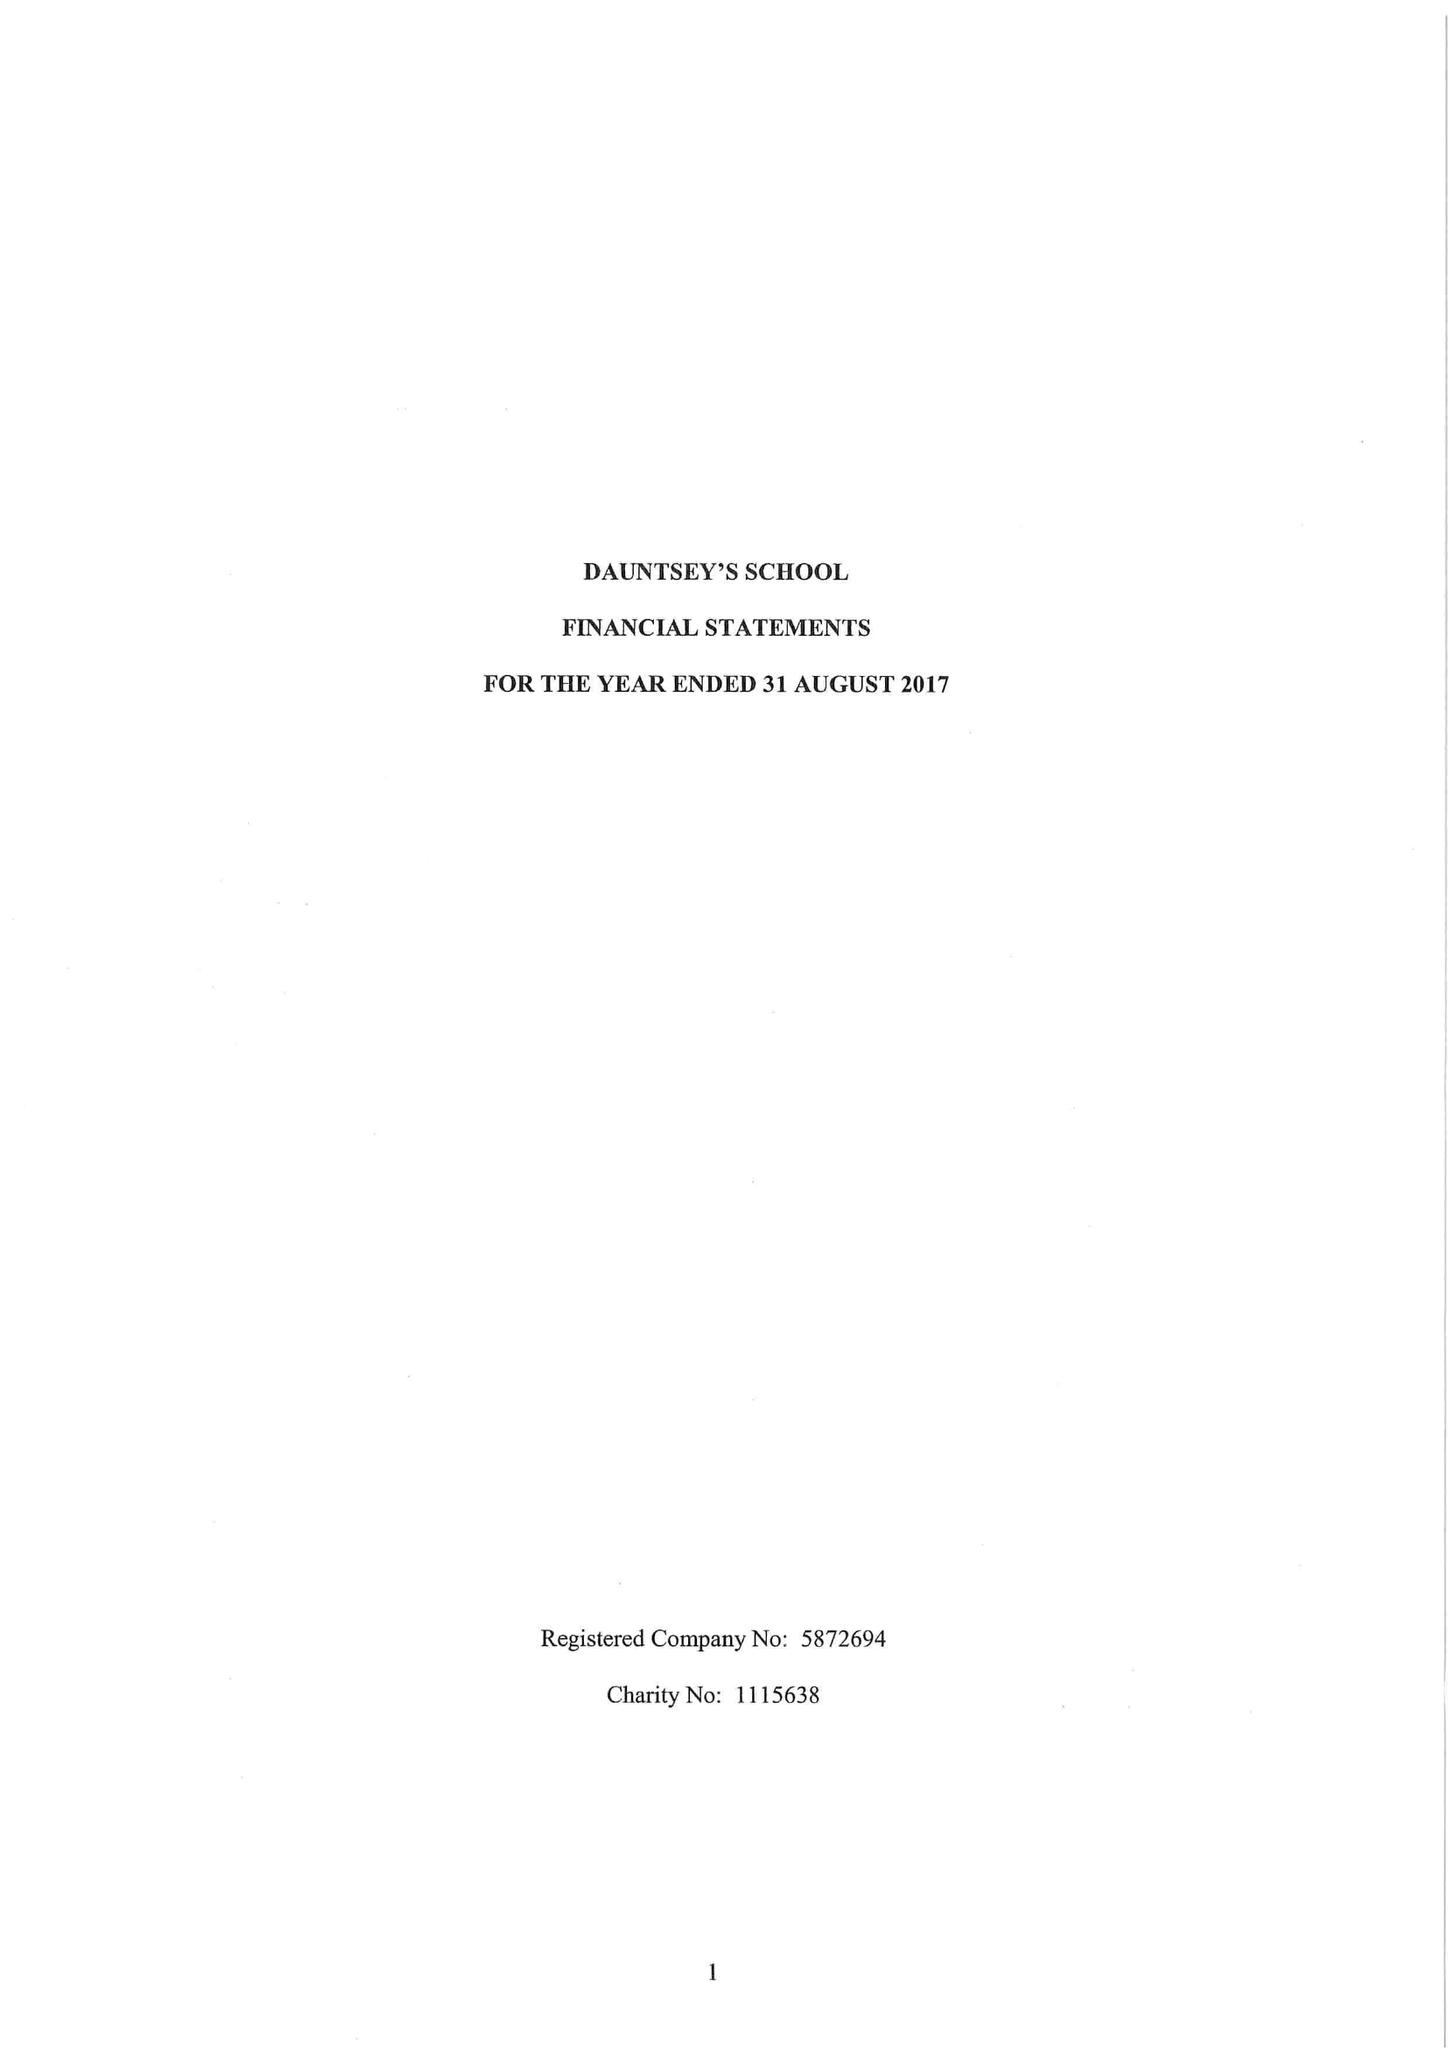What is the value for the charity_name?
Answer the question using a single word or phrase. Dauntsey's School 